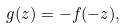Convert formula to latex. <formula><loc_0><loc_0><loc_500><loc_500>g ( z ) = - f ( - z ) ,</formula> 